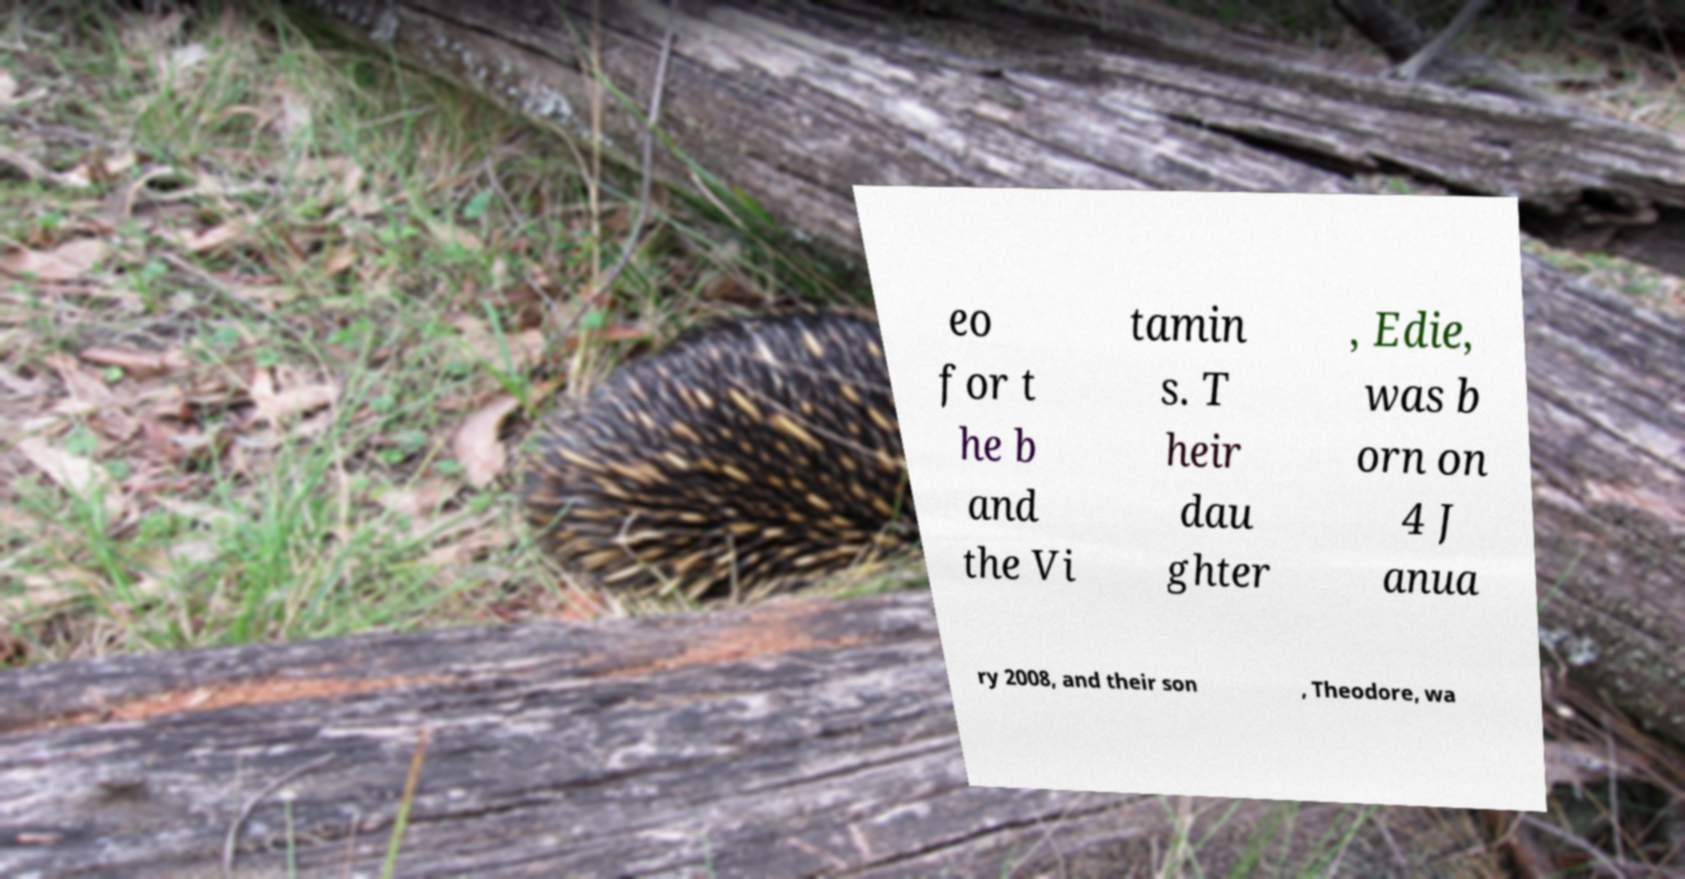Could you assist in decoding the text presented in this image and type it out clearly? eo for t he b and the Vi tamin s. T heir dau ghter , Edie, was b orn on 4 J anua ry 2008, and their son , Theodore, wa 